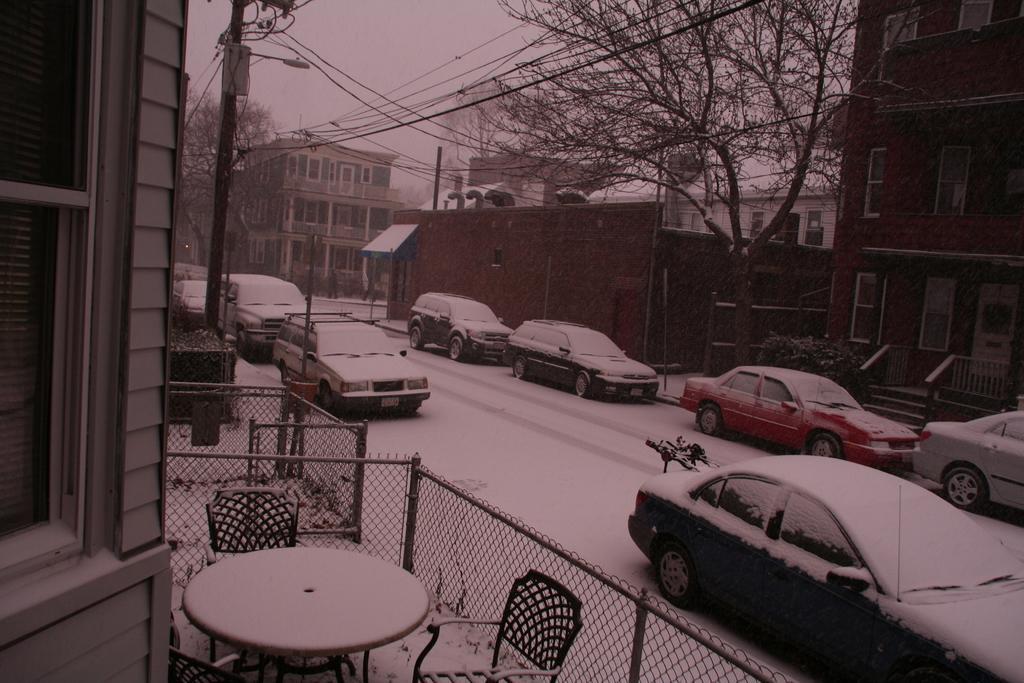Describe this image in one or two sentences. Here we can see a few cars which parked on this road. Here we can see a table and chairs arrangement which is bounded with this metal fence. Here we can see a house, a tree and an electric pole. 